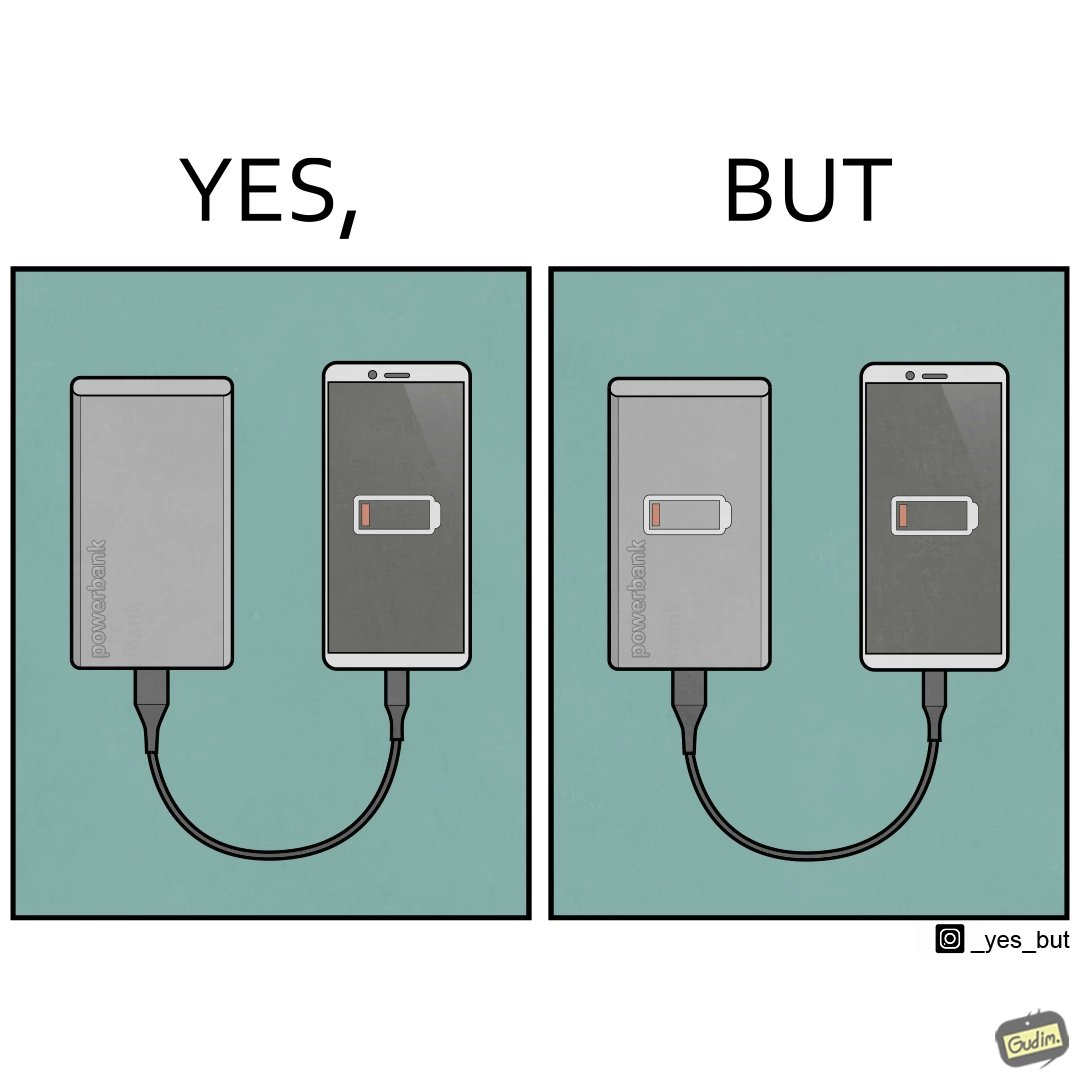Compare the left and right sides of this image. In the left part of the image: A smartphone being charged by a power bank (portable charger)  via  a short cable. Smartphone screen shows it's battery has no power left. In the right part of the image: A smartphone being charged by a power bank (portable charger)  via  a short cable. Smartphone screen shows it's battery has no power left. Power bank also  has no power left, indicated via  a symbol drawn on top of it. 